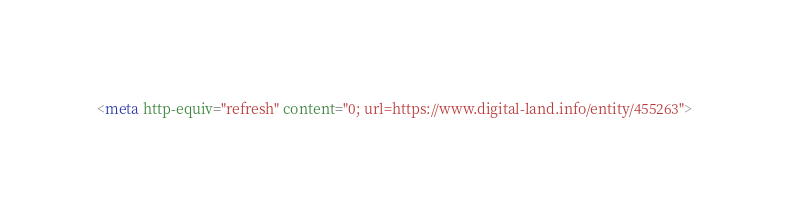<code> <loc_0><loc_0><loc_500><loc_500><_HTML_><meta http-equiv="refresh" content="0; url=https://www.digital-land.info/entity/455263"></code> 